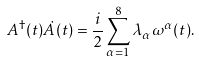<formula> <loc_0><loc_0><loc_500><loc_500>A ^ { \dagger } ( t ) \dot { A } ( t ) = \frac { i } { 2 } \sum _ { \alpha = 1 } ^ { 8 } \lambda _ { \alpha } \omega ^ { \alpha } ( t ) .</formula> 